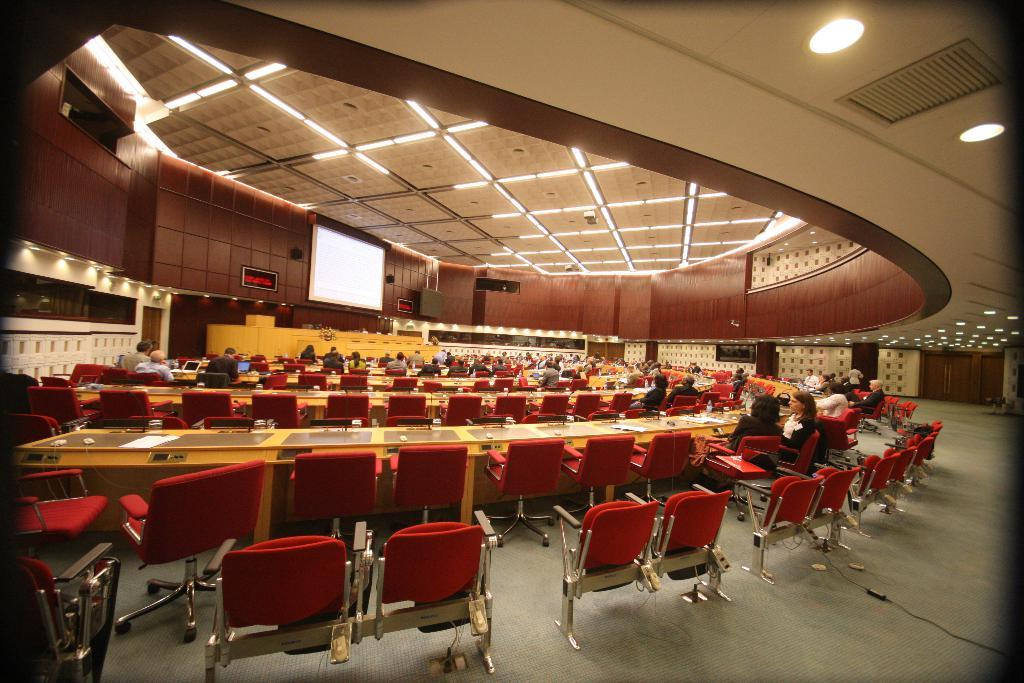What are the people in the image doing? The people in the image are sitting on chairs. What can be seen on the floor in the image? There are tables on the floor in the image. What type of items can be found on the tables? Papers and laptops are visible on the tables in the image. Can you describe the surroundings in the image? There are doors, walls, lights, a speaker, and a screen present in the image. The ceiling is also visible. Are there any unspecified objects in the image? Yes, there are some unspecified objects in the image. What type of soda is being served in the image? There is no soda present in the image. Can you see any boats or sailing equipment in the image? No, there are no boats or sailing equipment in the image. 